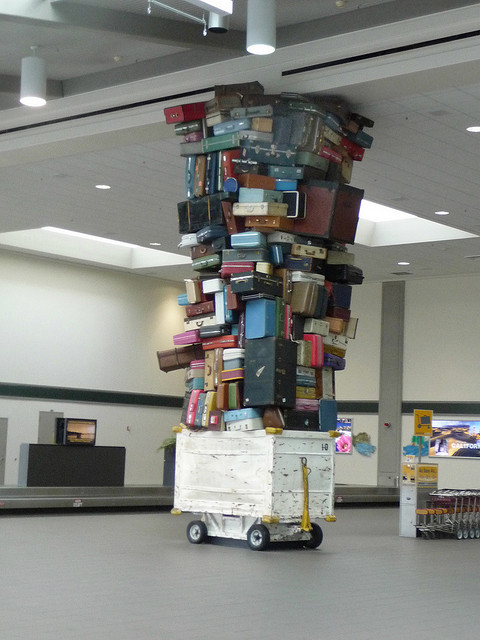If this is an artwork, what message do you think it conveys? If this is an artwork, it might be conveying messages about travel and mobility, the weight of personal history and belongings we carry with us, or the impact of tourism and movement on society and the environment. It invites the observer to ponder the stories behind each suitcase and the collective narrative they present. 